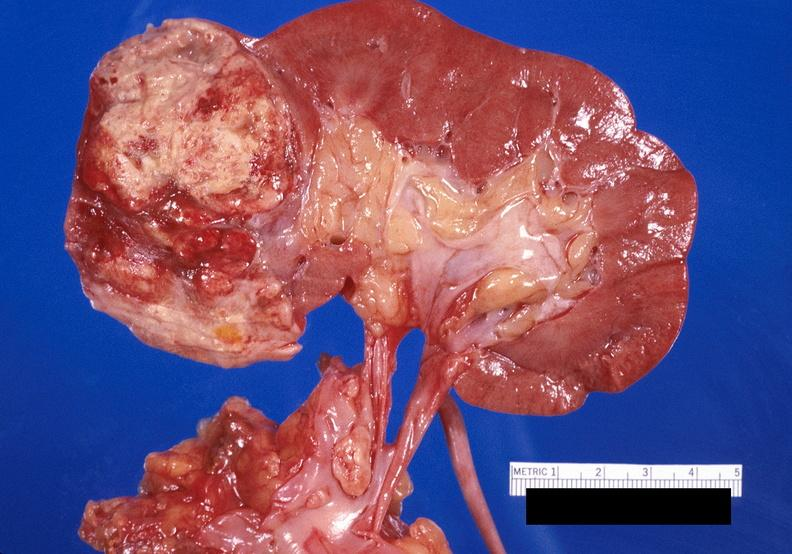does good example of muscle atrophy show renal cell carcinoma with extension into vena cava?
Answer the question using a single word or phrase. No 